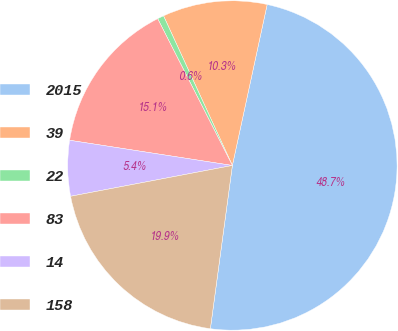Convert chart. <chart><loc_0><loc_0><loc_500><loc_500><pie_chart><fcel>2015<fcel>39<fcel>22<fcel>83<fcel>14<fcel>158<nl><fcel>48.74%<fcel>10.25%<fcel>0.63%<fcel>15.06%<fcel>5.44%<fcel>19.87%<nl></chart> 